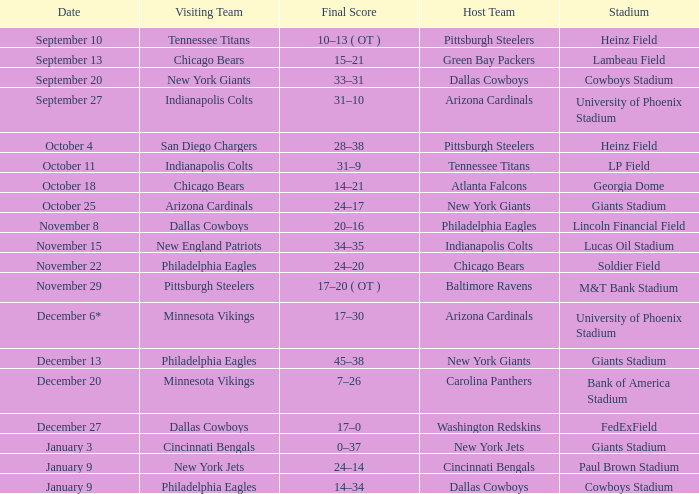Inform me of the end score for january 9 for cincinnati bengals. 24–14. 